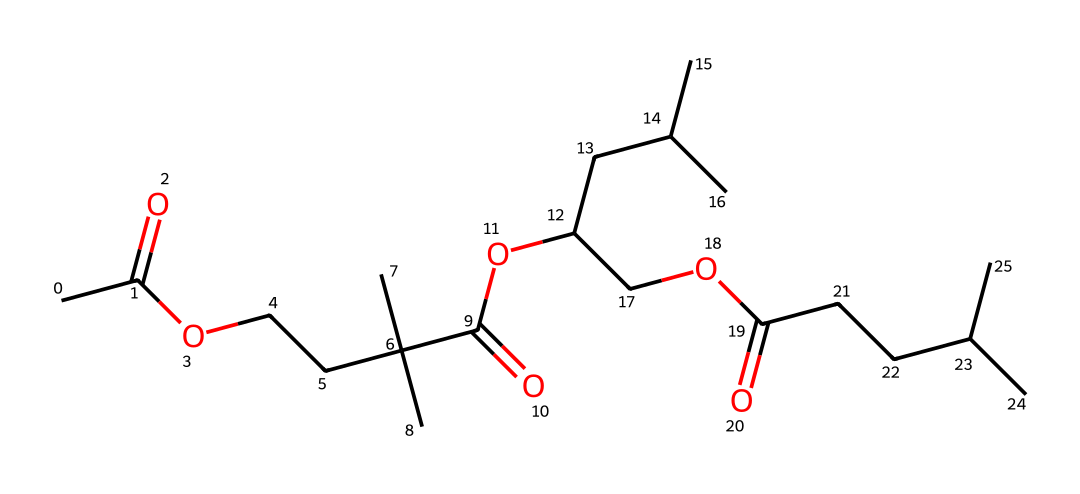What is the total number of carbon atoms in this chemical structure? To count the total number of carbon atoms, we can analyze the SMILES representation. In the provided SMILES, every occurrence of "C" represents a carbon atom, and we need to account for all branches and segments to total them correctly. By breaking down the structure, we find that there are 22 carbon atoms in total.
Answer: 22 How many ester functional groups are present in this chemical structure? The SMILES provides clues about the functional groups with the presence of "O" and "C(=O)" patterns, which indicate ester bonds. Upon closely examining the structure, we identify four ester linkages by counting every -COOC- segment present in the molecule.
Answer: 4 What is the general class of this lipid molecule? The presence of fatty acid chains and ester groups in this chemical structure indicates it belongs to a specific class of lipids. Given these characteristics and its importance in biological contexts, this molecule is classified as a triacylglycerol.
Answer: triacylglycerol What is the degree of saturation of the fatty acids represented in this structure? To determine the degree of saturation, we need to check for the presence of double bonds. In the SMILES representation, there are no indications of double bonds in the carbon chains, which means that all the fatty acids are saturated.
Answer: saturated Which part of this lipids chemical structure is essential for queen bee development? The essential part of the lipid structure that supports queen bee development is the specific fatty acids derived from the ester linkages. These compounds are crucial as they provide nutrition and hormonal cues specifically for the queen's growth and reproductive function.
Answer: fatty acids 